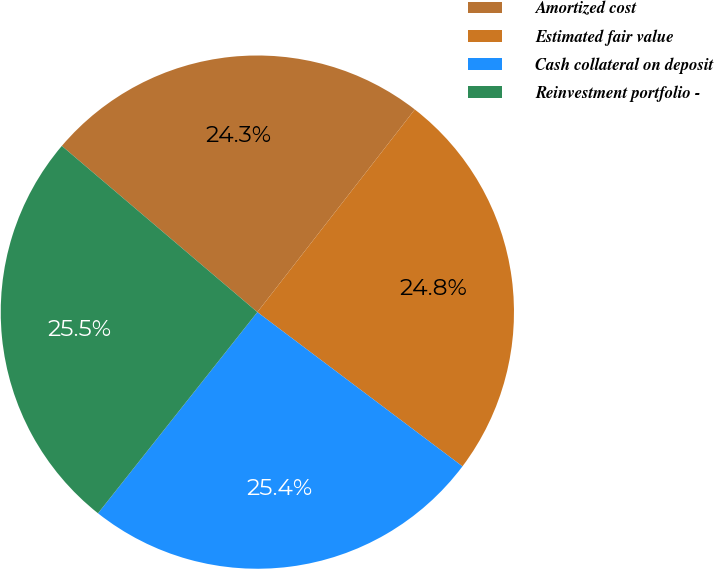Convert chart. <chart><loc_0><loc_0><loc_500><loc_500><pie_chart><fcel>Amortized cost<fcel>Estimated fair value<fcel>Cash collateral on deposit<fcel>Reinvestment portfolio -<nl><fcel>24.3%<fcel>24.75%<fcel>25.4%<fcel>25.55%<nl></chart> 